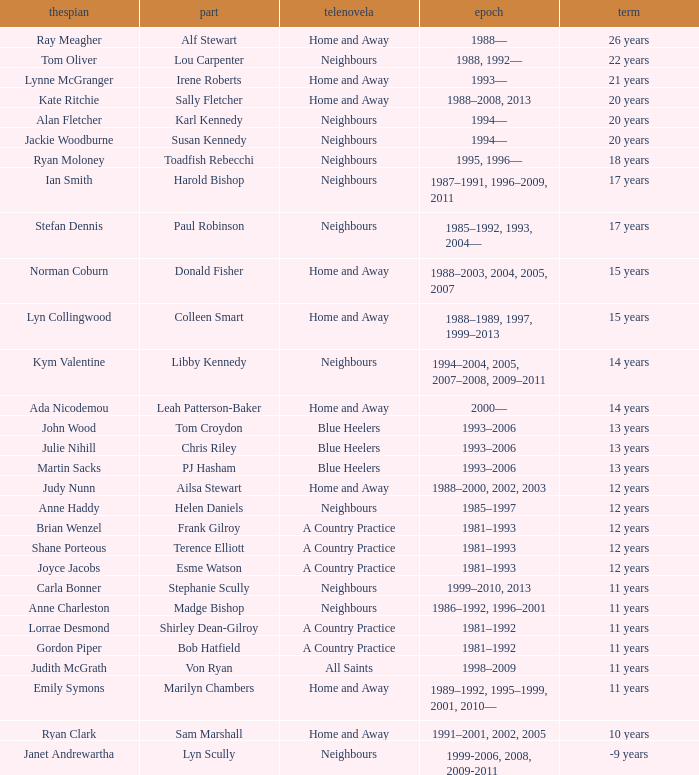What character was portrayed by the same actor for 12 years on Neighbours? Helen Daniels. 